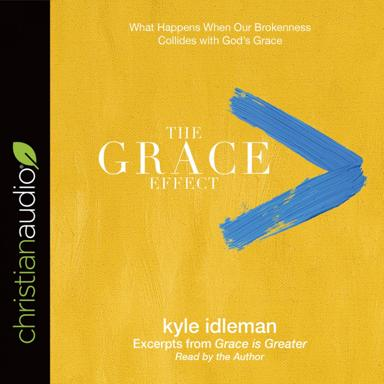Aside from 'Grace is Greater,' are there other key works by Kyle Idleman that might be connected to the themes explored in 'The Grace Effect'? Kyle Idleman has authored several works that delve into similar themes of faith, grace, and personal transformation. For example, 'Not a Fan' challenges readers to consider the true nature of their relationship with Christ, going beyond mere fandom to genuine discipleship. 'AHA: The God Moment That Changes Everything' looks at life-changing moments of revelation and action. These books complement the messages found in 'The Grace Effect,' expanding on the practical implications of living a grace-filled Christian life. 